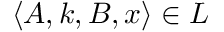<formula> <loc_0><loc_0><loc_500><loc_500>\langle A , k , B , x \rangle \in L</formula> 